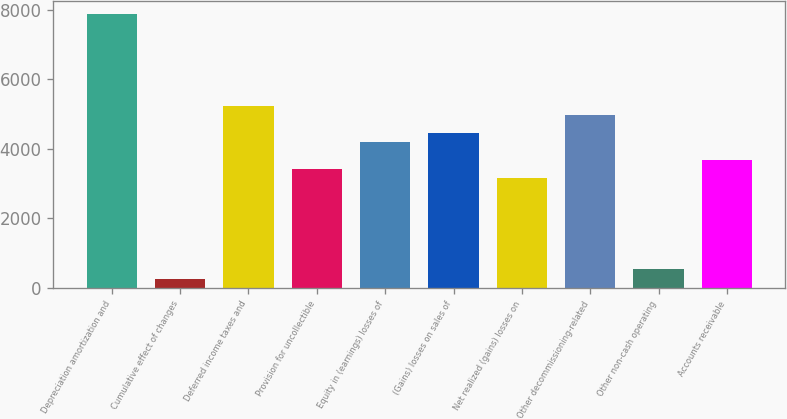Convert chart. <chart><loc_0><loc_0><loc_500><loc_500><bar_chart><fcel>Depreciation amortization and<fcel>Cumulative effect of changes<fcel>Deferred income taxes and<fcel>Provision for uncollectible<fcel>Equity in (earnings) losses of<fcel>(Gains) losses on sales of<fcel>Net realized (gains) losses on<fcel>Other decommissioning-related<fcel>Other non-cash operating<fcel>Accounts receivable<nl><fcel>7869<fcel>268.1<fcel>5248<fcel>3413.3<fcel>4199.6<fcel>4461.7<fcel>3151.2<fcel>4985.9<fcel>530.2<fcel>3675.4<nl></chart> 